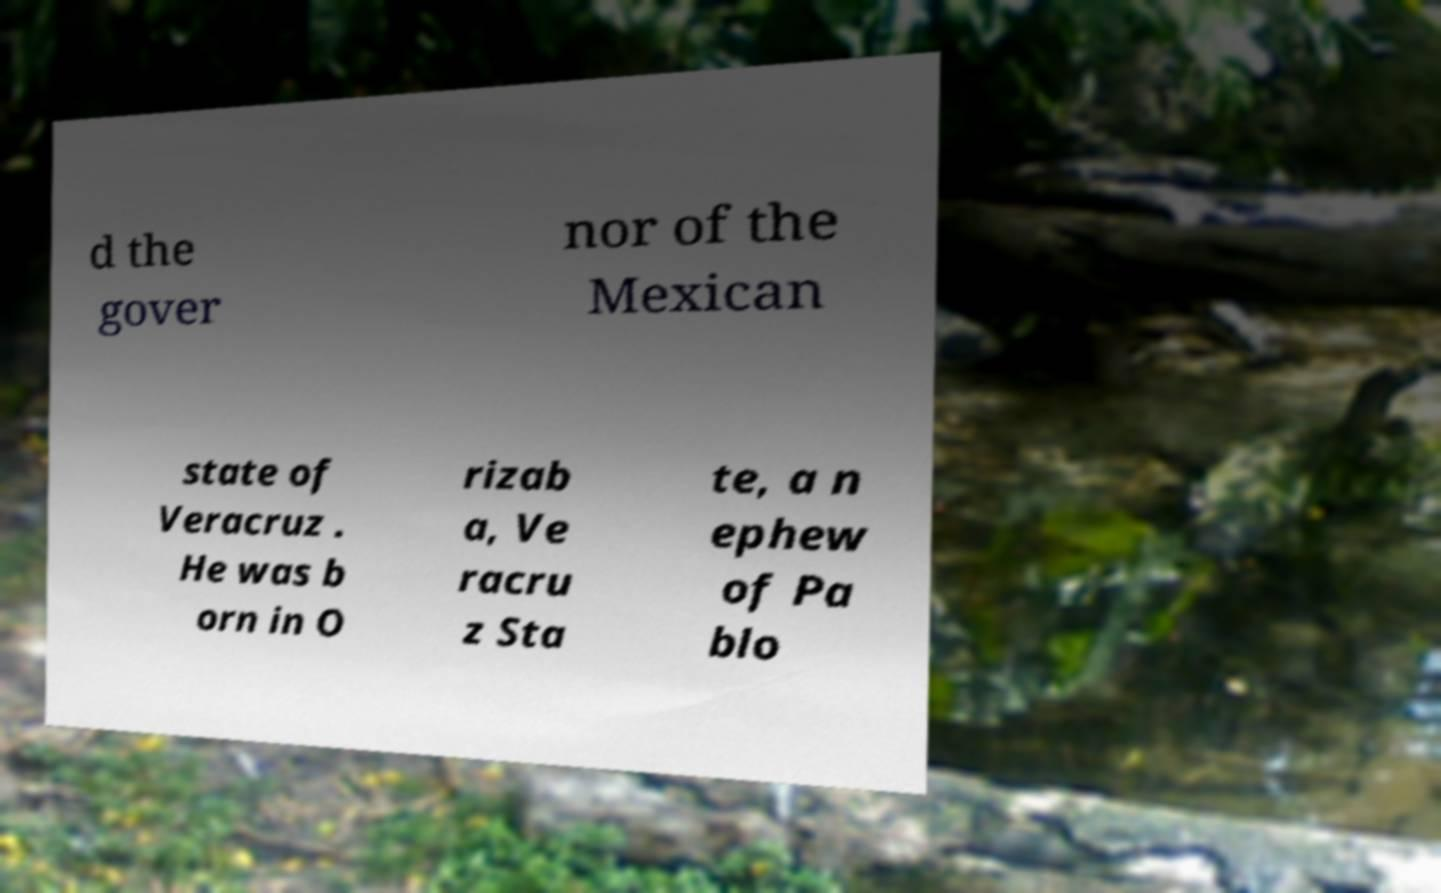Can you accurately transcribe the text from the provided image for me? d the gover nor of the Mexican state of Veracruz . He was b orn in O rizab a, Ve racru z Sta te, a n ephew of Pa blo 